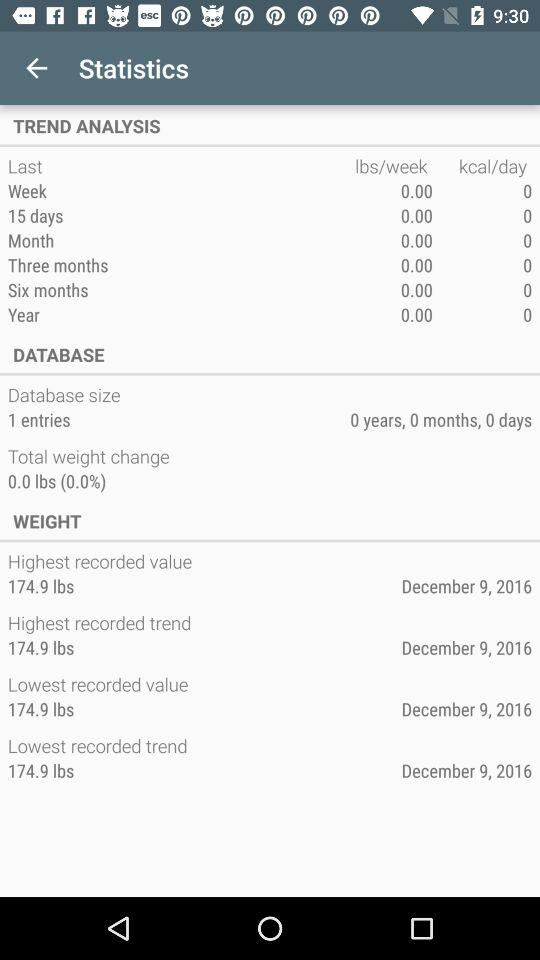What additional statistics are displayed related to weight trends? The image displays several weight-related statistics including the highest and lowest recorded weight, both noted as 174.9 lbs, recorded on the same date, December 9, 2016. 